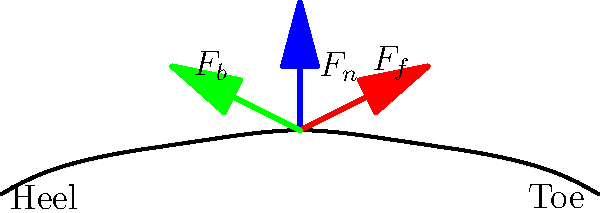During a powerful kick, three main forces act on a soccer cleat: the normal force ($F_n$), the forward force ($F_f$), and the backward force ($F_b$). If the magnitude of $F_n$ is 1000 N and the angle between $F_f$ and the horizontal is 30°, calculate the magnitude of $F_f$ required to maintain static equilibrium, assuming $F_b$ is 200 N and acts at an angle of 45° to the horizontal. To solve this problem, we'll use the concept of static equilibrium, where the sum of all forces must equal zero.

Step 1: Resolve forces into horizontal (x) and vertical (y) components.

$F_n$ (y-component): $F_n = 1000$ N
$F_f$ (x-component): $F_f \cos(30°)$
$F_f$ (y-component): $F_f \sin(30°)$
$F_b$ (x-component): $200 \cos(45°)$
$F_b$ (y-component): $200 \sin(45°)$

Step 2: Apply equilibrium conditions.

For x-direction: $\sum F_x = 0$
$F_f \cos(30°) - 200 \cos(45°) = 0$

For y-direction: $\sum F_y = 0$
$1000 + F_f \sin(30°) - 200 \sin(45°) = 0$

Step 3: Solve for $F_f$ using the x-direction equation.

$F_f \cos(30°) = 200 \cos(45°)$
$F_f = \frac{200 \cos(45°)}{\cos(30°)}$

Step 4: Calculate the result.

$F_f = \frac{200 \cdot \frac{\sqrt{2}}{2}}{\frac{\sqrt{3}}{2}} = \frac{200\sqrt{2}}{\sqrt{3}} \approx 163.3$ N

Therefore, the magnitude of $F_f$ required to maintain static equilibrium is approximately 163.3 N.
Answer: 163.3 N 